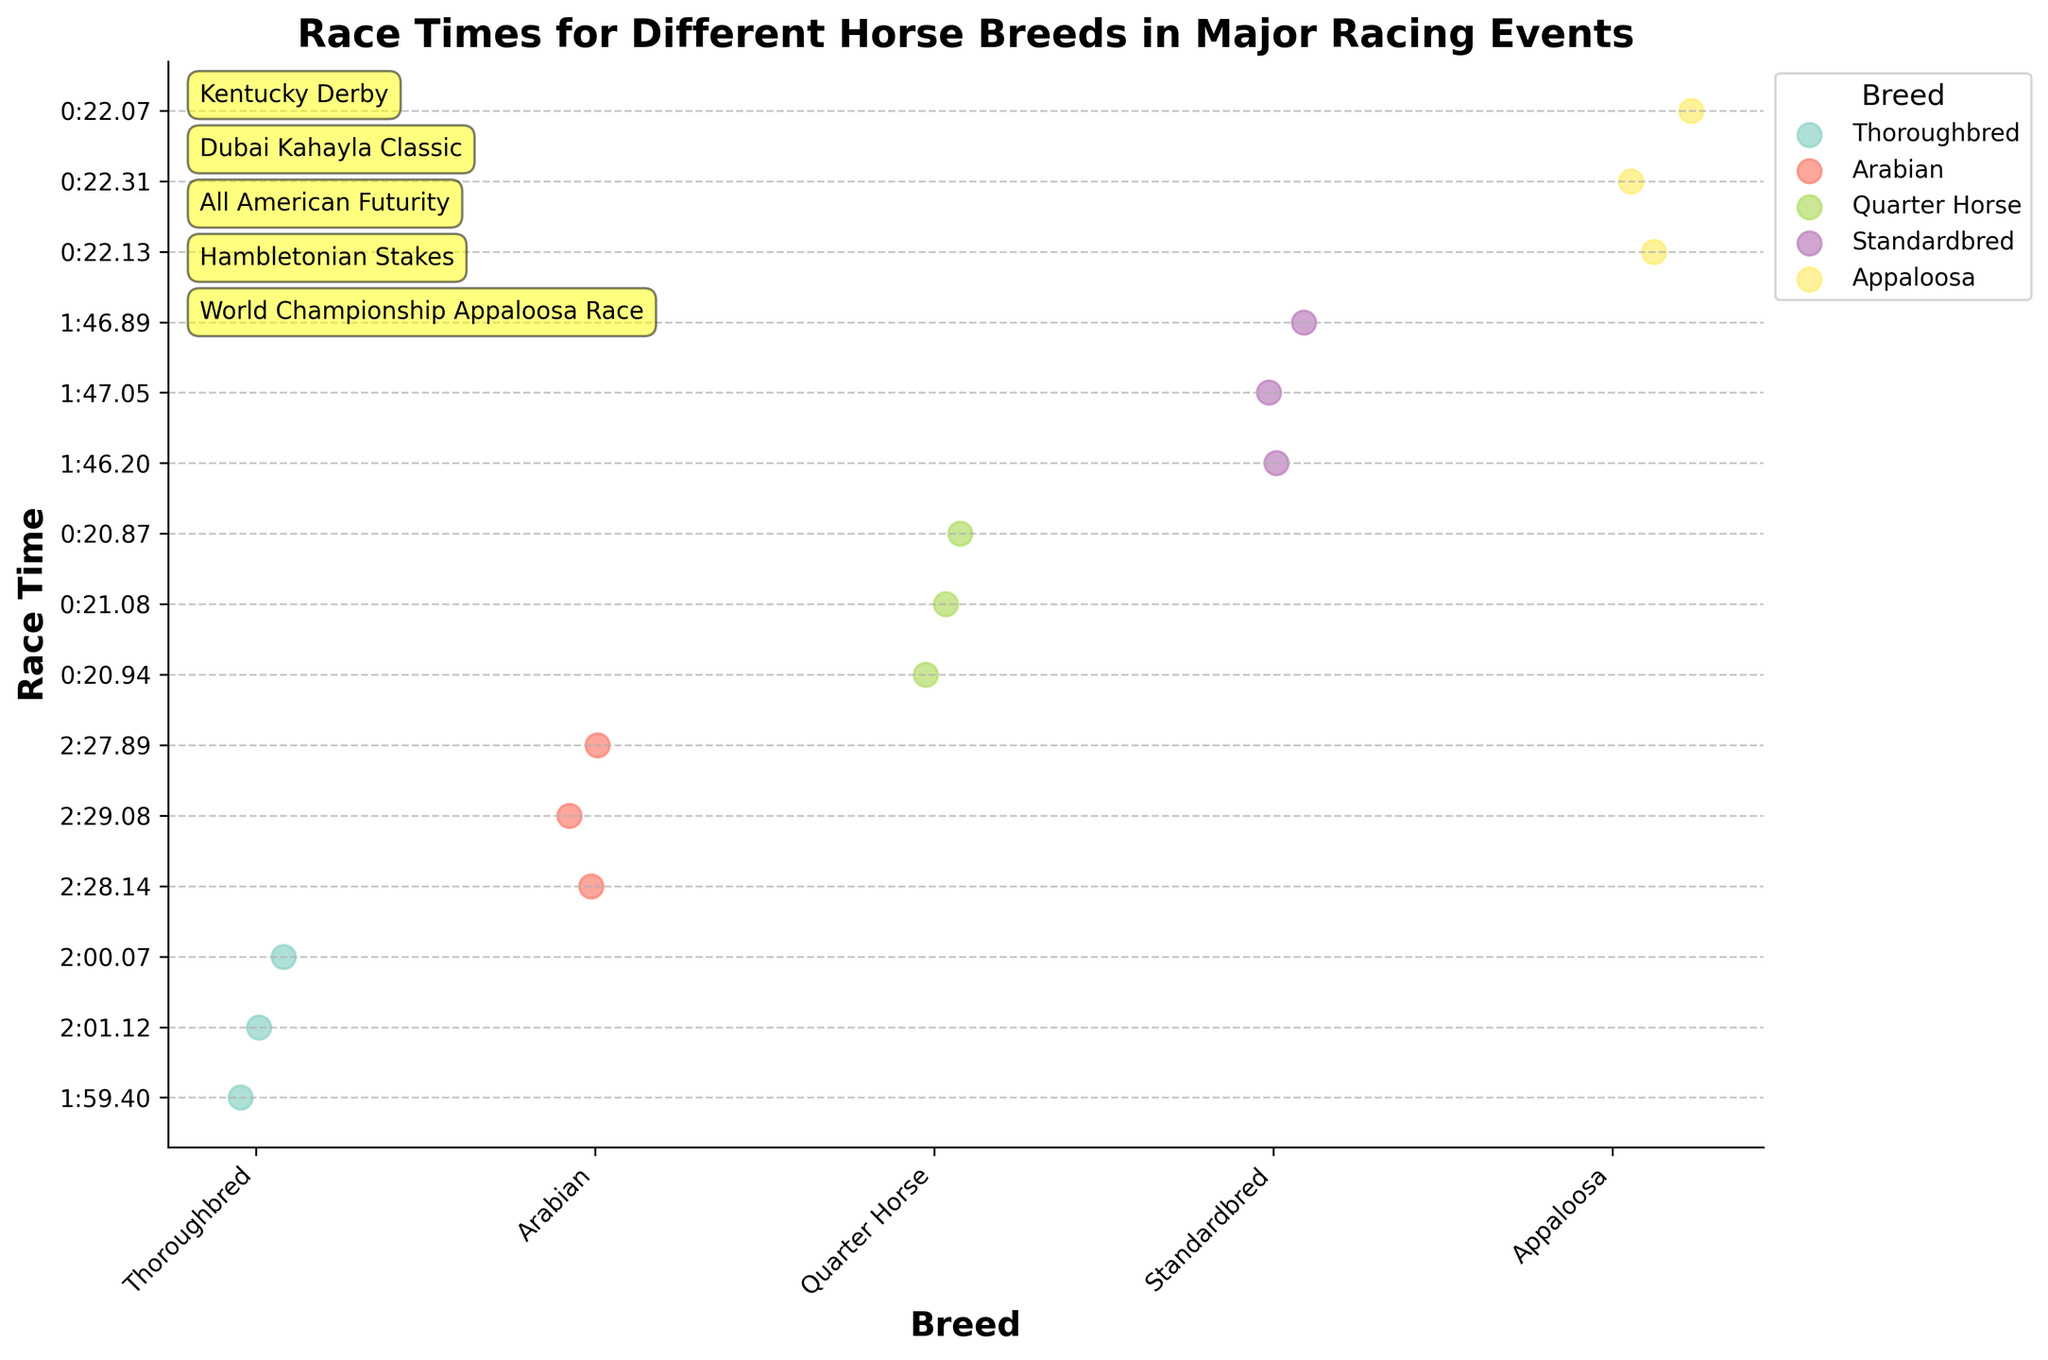What does the figure's title say? The title is located at the top of the figure and describes the main subject or purpose of the plot.
Answer: Race Times for Different Horse Breeds in Major Racing Events Which breed appears to have the fastest race times? By looking at the race times on the y-axis and comparing them, the Quarter Horse breed has the fastest race times as its points are closest to the bottom (shorter times).
Answer: Quarter Horse How many breeds are displayed in the plot? By counting the unique labels on the x-axis, we can see the number of breeds displayed.
Answer: Five Which breed shows the largest variation in race times? The breed with the largest vertical spread of data points (along the y-axis) has the largest variation in race times.
Answer: Arabian What is the average race time for Thoroughbreds? The individual race times for Thoroughbreds are visible within its breed category, and we can calculate the average by summing these times and dividing by the number of data points. The times are 1:59.40, 2:01.12, and 2:00.07. Converting to seconds: 1:59.40 → 119.40s, 2:01.12 → 121.12s, 2:00.07 → 120.07s. Thus, the average is (119.40 + 121.12 + 120.07) / 3 ≈ 120.20 seconds.
Answer: Approximately 120.20 seconds Which event is annotated closest to the top of the figure? By examining the annotations near the top-left of the figure, the event written at the highest point is the closest to the top.
Answer: Kentucky Derby Which two breeds have the most similar race times on average? By comparing the average race times for each breed, we must find the two breeds with the closest average times. Thoroughbred's average is approximately 120.20 seconds, and Standardbred's times are 1:46.20 (106.20s), 1:47.05 (107.05s), 1:46.89 (106.89s), averaging to (106.20 + 107.05 + 106.89) / 3 ≈ 106.71 seconds. Similarly calculated, we find Thoroughbred and Standardbred to be the closest.
Answer: Thoroughbred and Standardbred How many data points are there for the Quarter Horse breed? By counting the individual data points (dots) in the Quarter Horse category, we find the number of race times recorded.
Answer: Three Which breed participates in the race with the longest race times? By observing the maximum y-axis values for each breed, the breed with the highest points is participating in the race with longer times.
Answer: Arabian What is the color representation for Appaloosas? The color assigned to each breed can be identified by looking at the color of the points associated with Appaloosas.
Answer: Appaloosa points are represented in the color specific to Appaloosa in the plot, typically indicated by the color legend 